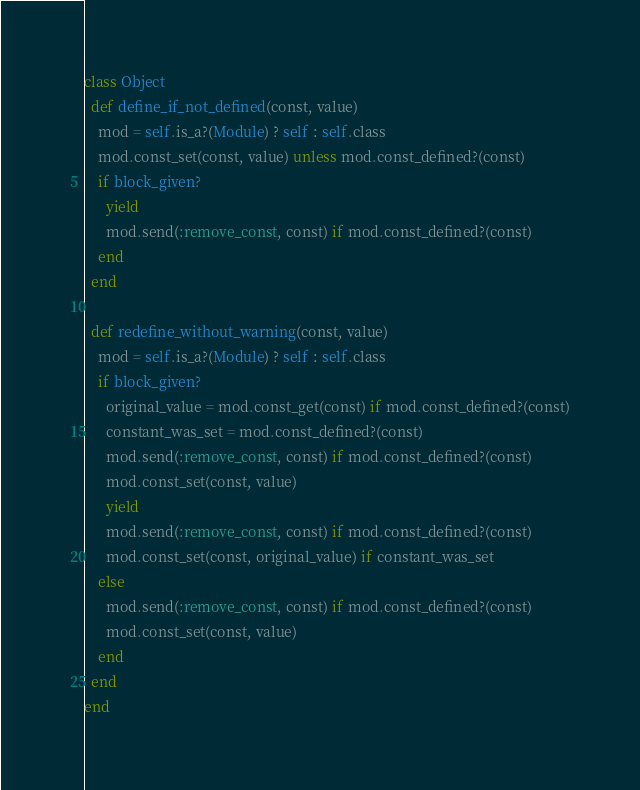<code> <loc_0><loc_0><loc_500><loc_500><_Ruby_>class Object
  def define_if_not_defined(const, value)
    mod = self.is_a?(Module) ? self : self.class
    mod.const_set(const, value) unless mod.const_defined?(const)
    if block_given?
      yield      
      mod.send(:remove_const, const) if mod.const_defined?(const)
    end
  end

  def redefine_without_warning(const, value)
    mod = self.is_a?(Module) ? self : self.class
    if block_given?
      original_value = mod.const_get(const) if mod.const_defined?(const)
      constant_was_set = mod.const_defined?(const)
      mod.send(:remove_const, const) if mod.const_defined?(const)
      mod.const_set(const, value)
      yield
      mod.send(:remove_const, const) if mod.const_defined?(const)
      mod.const_set(const, original_value) if constant_was_set
    else
      mod.send(:remove_const, const) if mod.const_defined?(const)
      mod.const_set(const, value)
    end
  end
end
</code> 